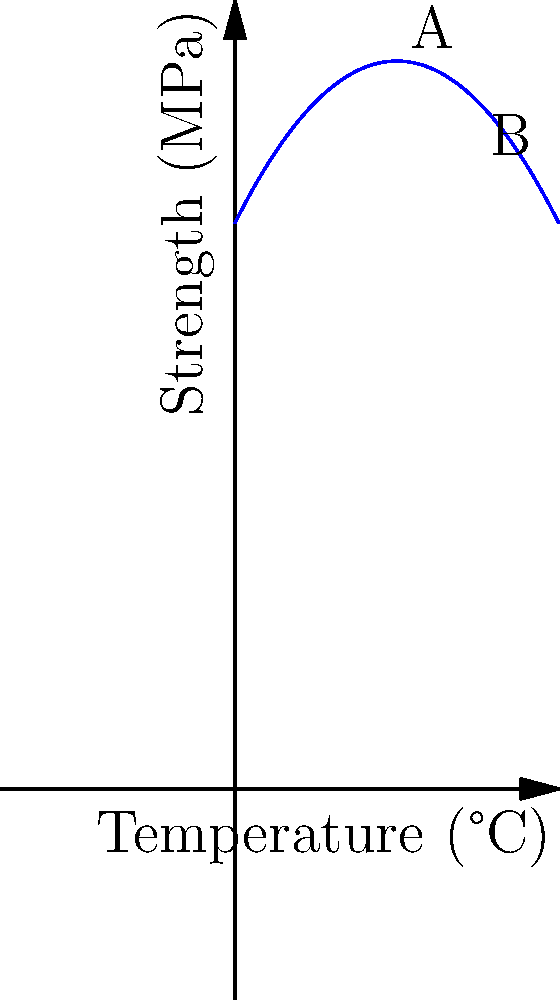As an eco-friendly polymer manufacturer, you've developed a new biodegradable plastic. The relationship between its strength and temperature is modeled by the quadratic equation $S(T) = -0.05T^2 + 2T + 70$, where $S$ is the strength in MPa and $T$ is the temperature in °C. Using the graph, determine the change in strength when the temperature increases from 20°C (point A) to 30°C (point B). To solve this problem, we'll follow these steps:

1) First, let's calculate the strength at 20°C (point A):
   $S(20) = -0.05(20)^2 + 2(20) + 70$
   $= -0.05(400) + 40 + 70$
   $= -20 + 40 + 70 = 90$ MPa

2) Now, let's calculate the strength at 30°C (point B):
   $S(30) = -0.05(30)^2 + 2(30) + 70$
   $= -0.05(900) + 60 + 70$
   $= -45 + 60 + 70 = 85$ MPa

3) To find the change in strength, we subtract:
   Change in strength = $S(30) - S(20) = 85 - 90 = -5$ MPa

The negative value indicates a decrease in strength as the temperature increases from 20°C to 30°C.
Answer: -5 MPa 